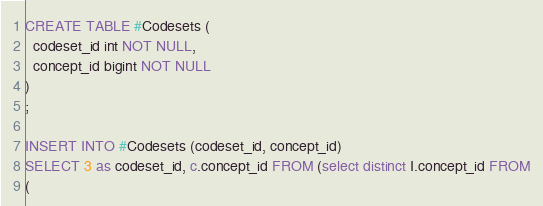Convert code to text. <code><loc_0><loc_0><loc_500><loc_500><_SQL_>CREATE TABLE #Codesets (
  codeset_id int NOT NULL,
  concept_id bigint NOT NULL
)
;

INSERT INTO #Codesets (codeset_id, concept_id)
SELECT 3 as codeset_id, c.concept_id FROM (select distinct I.concept_id FROM
( </code> 